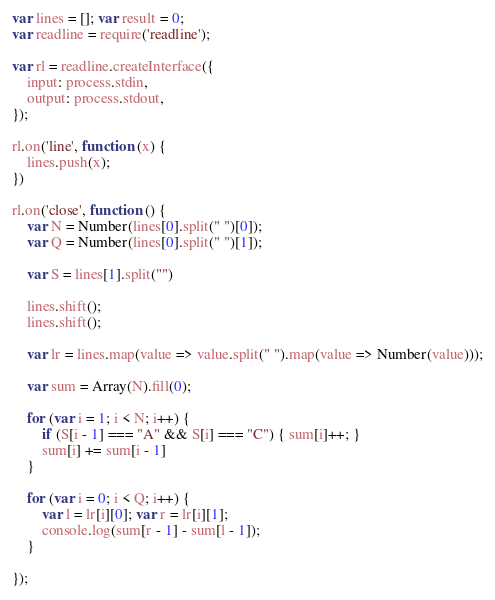<code> <loc_0><loc_0><loc_500><loc_500><_JavaScript_>var lines = []; var result = 0;
var readline = require('readline');

var rl = readline.createInterface({
    input: process.stdin,
    output: process.stdout,
});

rl.on('line', function (x) {
    lines.push(x);
})

rl.on('close', function () {
    var N = Number(lines[0].split(" ")[0]);
    var Q = Number(lines[0].split(" ")[1]);

    var S = lines[1].split("")

    lines.shift();
    lines.shift();

    var lr = lines.map(value => value.split(" ").map(value => Number(value)));

    var sum = Array(N).fill(0);

    for (var i = 1; i < N; i++) {
        if (S[i - 1] === "A" && S[i] === "C") { sum[i]++; }
        sum[i] += sum[i - 1]
    }

    for (var i = 0; i < Q; i++) {
        var l = lr[i][0]; var r = lr[i][1];
        console.log(sum[r - 1] - sum[l - 1]);
    }

});</code> 